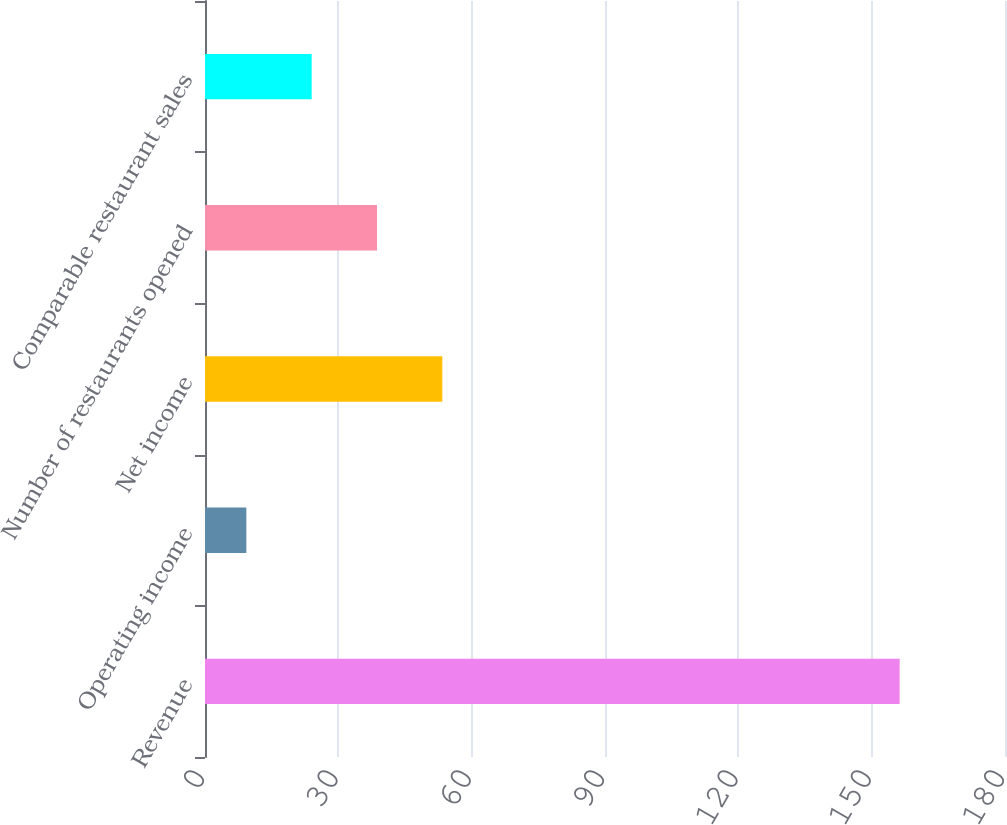Convert chart to OTSL. <chart><loc_0><loc_0><loc_500><loc_500><bar_chart><fcel>Revenue<fcel>Operating income<fcel>Net income<fcel>Number of restaurants opened<fcel>Comparable restaurant sales<nl><fcel>156.3<fcel>9.3<fcel>53.4<fcel>38.7<fcel>24<nl></chart> 